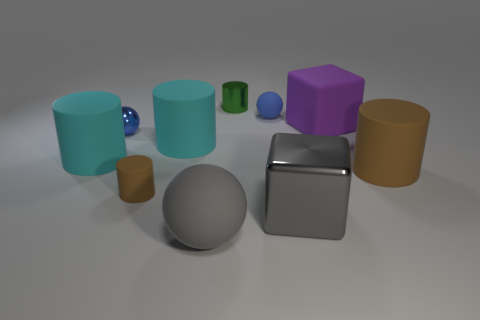Subtract all blue spheres. How many were subtracted if there are1blue spheres left? 1 Subtract 2 cylinders. How many cylinders are left? 3 Subtract all tiny matte cylinders. How many cylinders are left? 4 Subtract all green cylinders. How many cylinders are left? 4 Subtract all purple cylinders. Subtract all red cubes. How many cylinders are left? 5 Subtract all cubes. How many objects are left? 8 Subtract all purple rubber things. Subtract all large brown objects. How many objects are left? 8 Add 4 big matte blocks. How many big matte blocks are left? 5 Add 4 large gray rubber spheres. How many large gray rubber spheres exist? 5 Subtract 0 yellow balls. How many objects are left? 10 